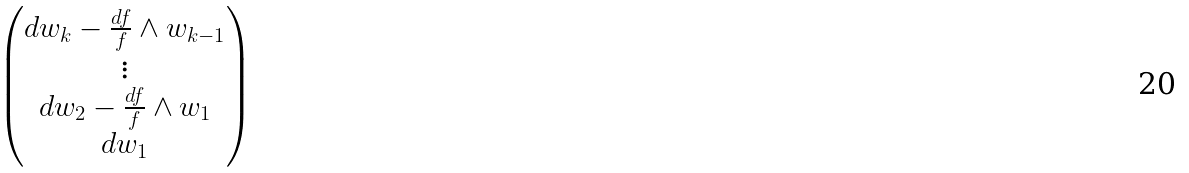Convert formula to latex. <formula><loc_0><loc_0><loc_500><loc_500>\begin{pmatrix} { d w _ { k } - \frac { d f } { f } \wedge w _ { k - 1 } } \\ { \vdots } \\ { d w _ { 2 } - \frac { d f } { f } \wedge w _ { 1 } } \\ { d w _ { 1 } } \end{pmatrix}</formula> 